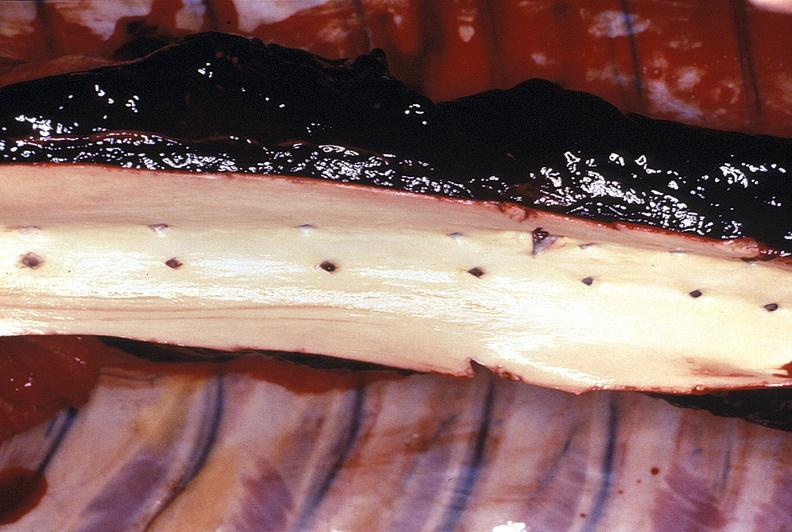does chest and abdomen slide show aorta, normal intima?
Answer the question using a single word or phrase. No 